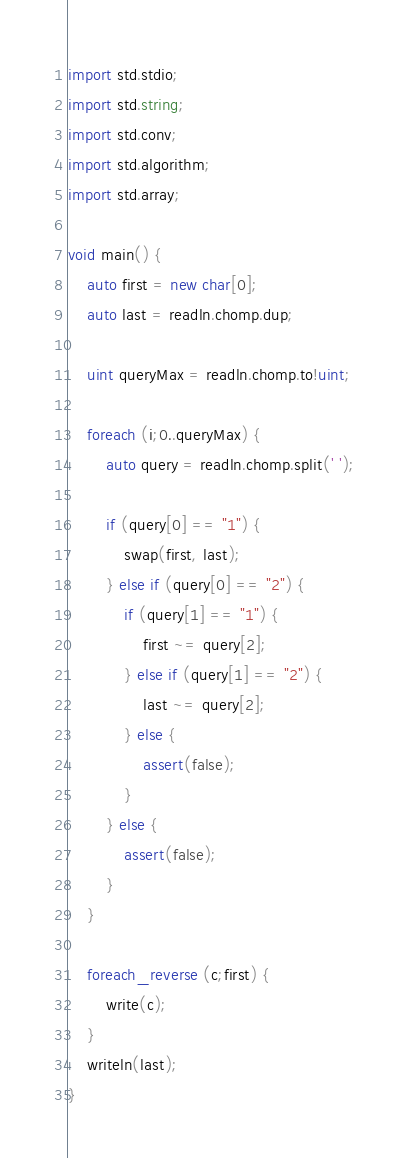Convert code to text. <code><loc_0><loc_0><loc_500><loc_500><_D_>import std.stdio;
import std.string;
import std.conv;
import std.algorithm;
import std.array;

void main() {
	auto first = new char[0];
	auto last = readln.chomp.dup;

	uint queryMax = readln.chomp.to!uint;

	foreach (i;0..queryMax) {
		auto query = readln.chomp.split(' ');

		if (query[0] == "1") {
			swap(first, last);
		} else if (query[0] == "2") {
			if (query[1] == "1") {
				first ~= query[2];
			} else if (query[1] == "2") {
				last ~= query[2];
			} else {
				assert(false);
			}
		} else {
			assert(false);
		}
	}

	foreach_reverse (c;first) {
		write(c);
	}
	writeln(last);
}
</code> 